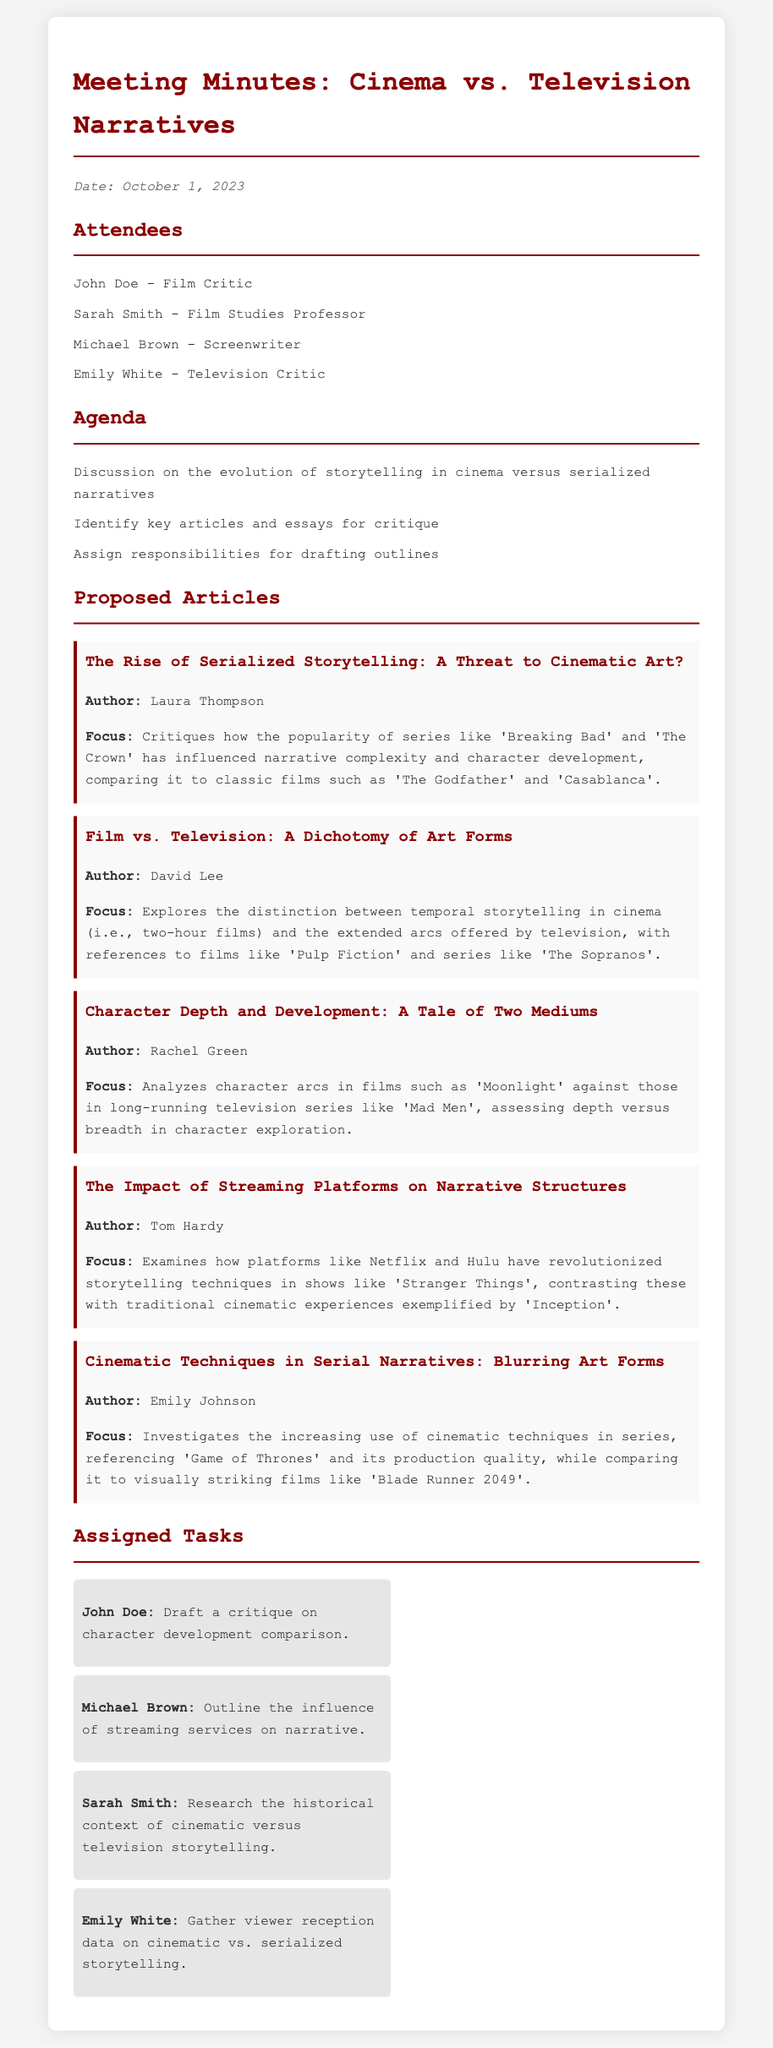What is the date of the meeting? The date is explicitly mentioned in the document under the date section.
Answer: October 1, 2023 Who is the author of the article titled "Film vs. Television: A Dichotomy of Art Forms"? The document lists authors for each proposed article, including their titles.
Answer: David Lee What is the focus of Laura Thompson's article? The focus of each article is described immediately after the author’s name within the proposed articles section.
Answer: Narrative complexity and character development Which attendee is responsible for drafting a critique on character development comparison? The document clearly assigns specific tasks to attendees, indicating who is responsible for what.
Answer: John Doe How many proposed articles are listed in the document? The number of articles can be counted from the proposed articles section.
Answer: Five What does the article "The Impact of Streaming Platforms on Narrative Structures" examine? Each proposed article includes a focus that describes its content.
Answer: Platforms like Netflix and Hulu What task is assigned to Sarah Smith? The assigned tasks section specifies each attendee's responsibilities.
Answer: Research the historical context of cinematic versus television storytelling What is the title of the article authored by Rachel Green? The document provides the titles of all proposed articles along with their authors.
Answer: Character Depth and Development: A Tale of Two Mediums What is the main question discussed in the agenda? The agenda clearly outlines the main topic of discussion for the meeting.
Answer: Evolution of storytelling in cinema versus serialized narratives 